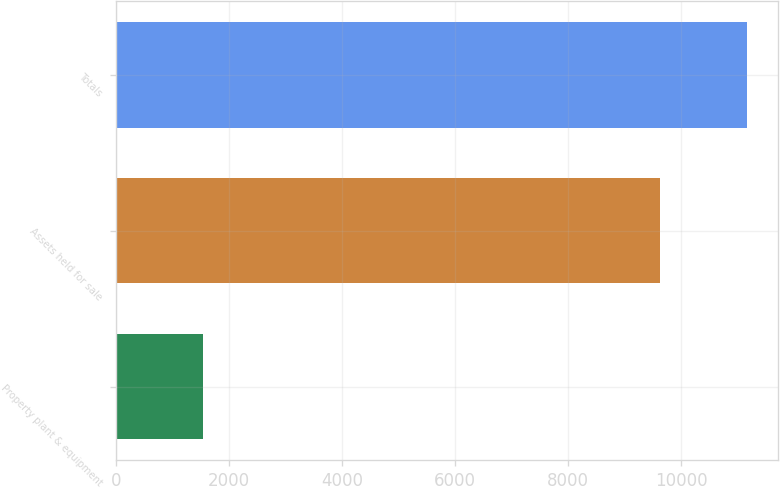Convert chart to OTSL. <chart><loc_0><loc_0><loc_500><loc_500><bar_chart><fcel>Property plant & equipment<fcel>Assets held for sale<fcel>Totals<nl><fcel>1536<fcel>9625<fcel>11161<nl></chart> 